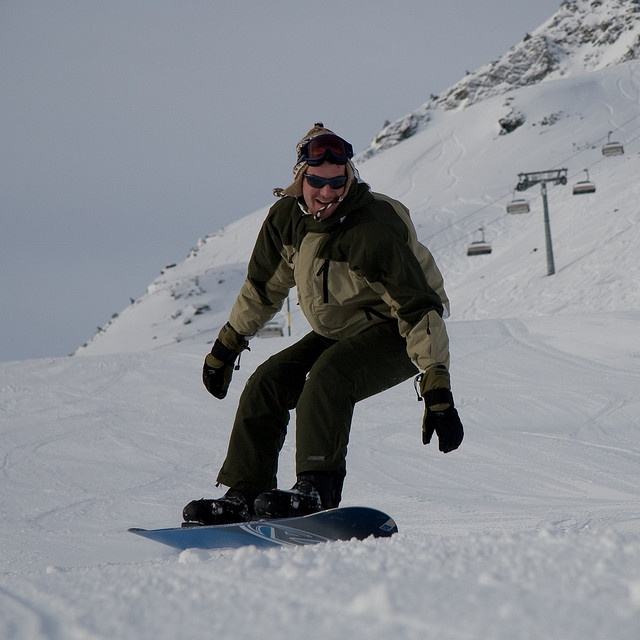Describe the objects in this image and their specific colors. I can see people in gray, black, and darkgray tones, snowboard in gray, black, blue, and navy tones, and bench in gray and darkgray tones in this image. 